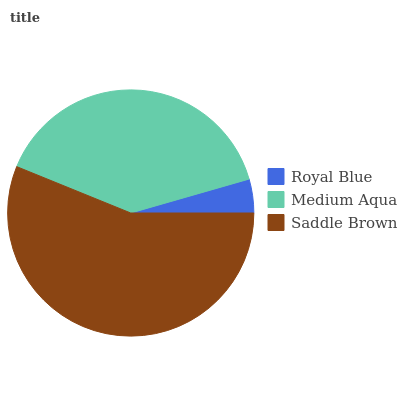Is Royal Blue the minimum?
Answer yes or no. Yes. Is Saddle Brown the maximum?
Answer yes or no. Yes. Is Medium Aqua the minimum?
Answer yes or no. No. Is Medium Aqua the maximum?
Answer yes or no. No. Is Medium Aqua greater than Royal Blue?
Answer yes or no. Yes. Is Royal Blue less than Medium Aqua?
Answer yes or no. Yes. Is Royal Blue greater than Medium Aqua?
Answer yes or no. No. Is Medium Aqua less than Royal Blue?
Answer yes or no. No. Is Medium Aqua the high median?
Answer yes or no. Yes. Is Medium Aqua the low median?
Answer yes or no. Yes. Is Saddle Brown the high median?
Answer yes or no. No. Is Saddle Brown the low median?
Answer yes or no. No. 